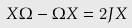<formula> <loc_0><loc_0><loc_500><loc_500>X \Omega - \Omega X = 2 J X</formula> 